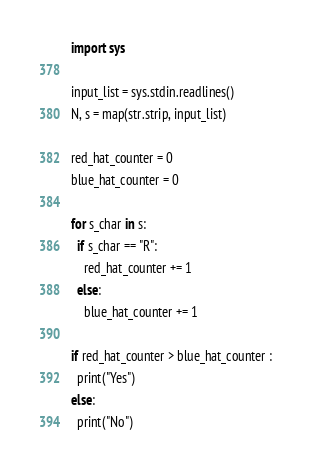Convert code to text. <code><loc_0><loc_0><loc_500><loc_500><_Python_>import sys

input_list = sys.stdin.readlines() 
N, s = map(str.strip, input_list)

red_hat_counter = 0
blue_hat_counter = 0

for s_char in s:
  if s_char == "R":
    red_hat_counter += 1
  else:
    blue_hat_counter += 1

if red_hat_counter > blue_hat_counter :
  print("Yes")
else:
  print("No")</code> 